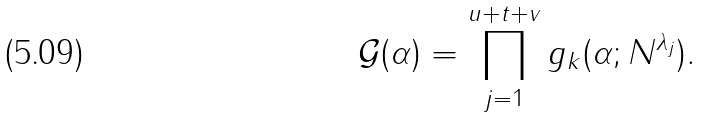<formula> <loc_0><loc_0><loc_500><loc_500>\mathcal { G } ( \alpha ) = \prod _ { j = 1 } ^ { u + t + v } g _ { k } ( \alpha ; N ^ { \lambda _ { j } } ) .</formula> 